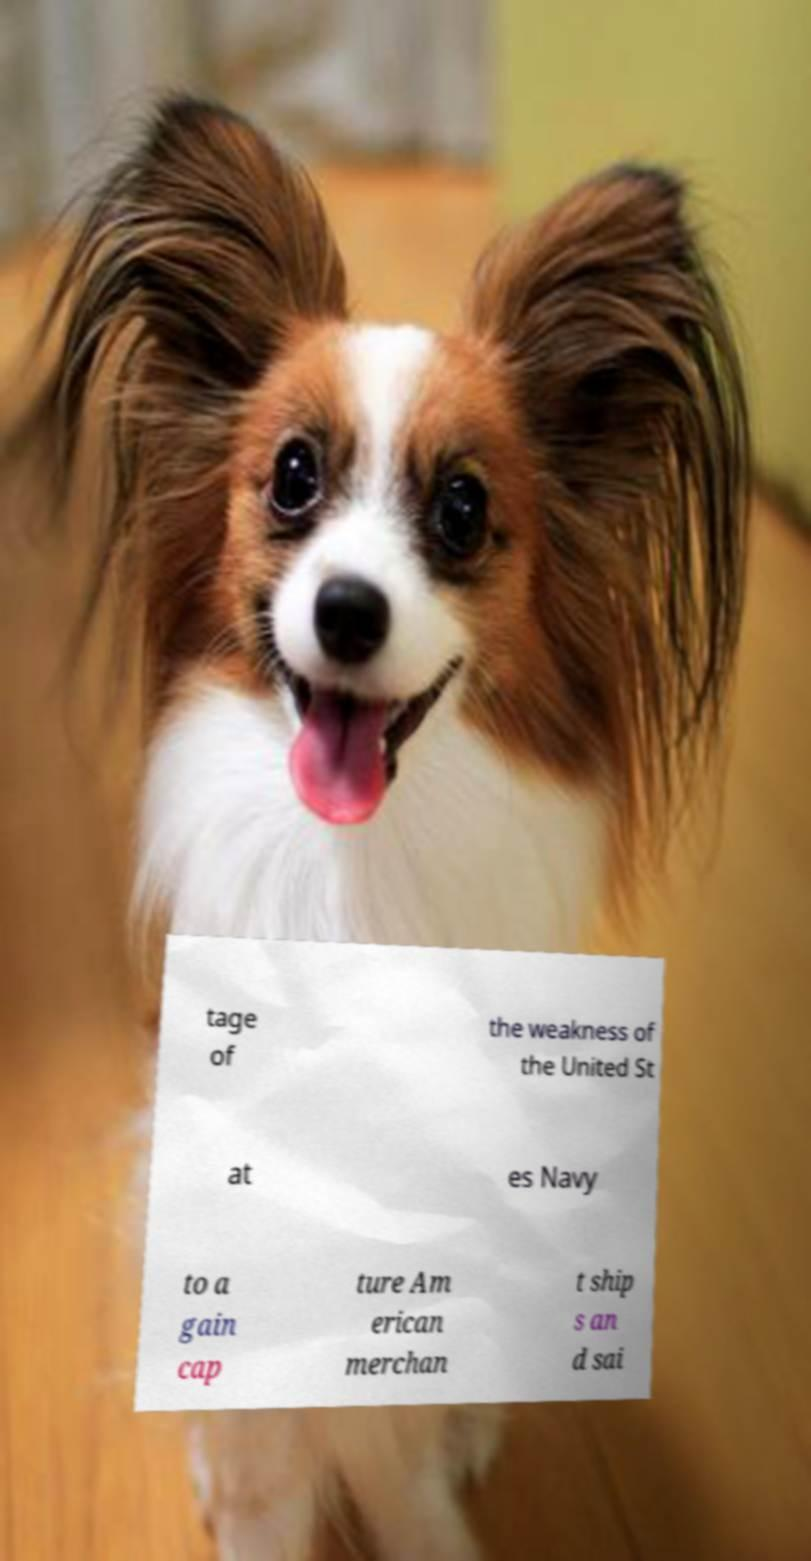For documentation purposes, I need the text within this image transcribed. Could you provide that? tage of the weakness of the United St at es Navy to a gain cap ture Am erican merchan t ship s an d sai 